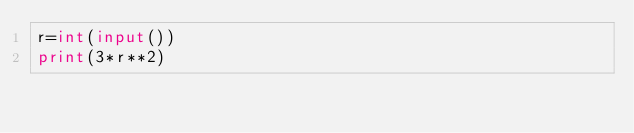<code> <loc_0><loc_0><loc_500><loc_500><_Python_>r=int(input())
print(3*r**2)</code> 